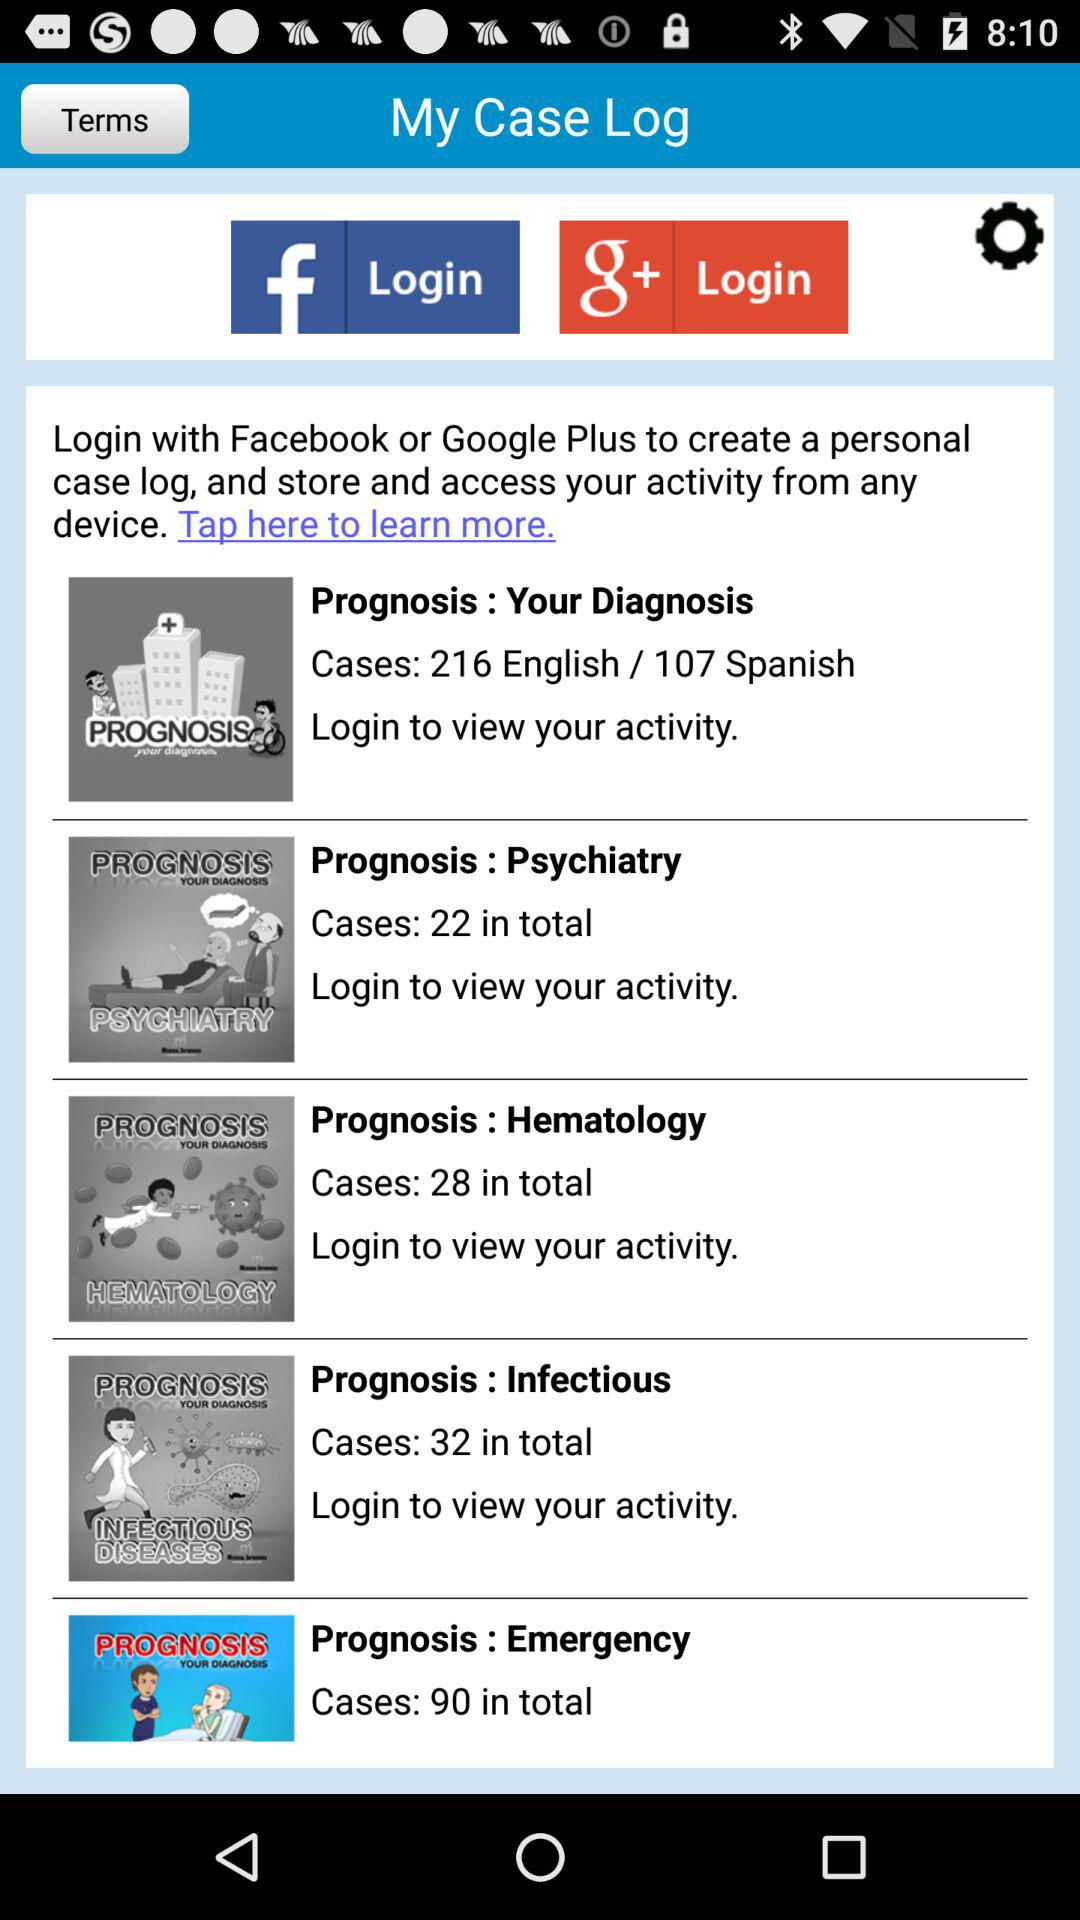How many cases in total are there in "Hematology"? There are 28 cases in total. 